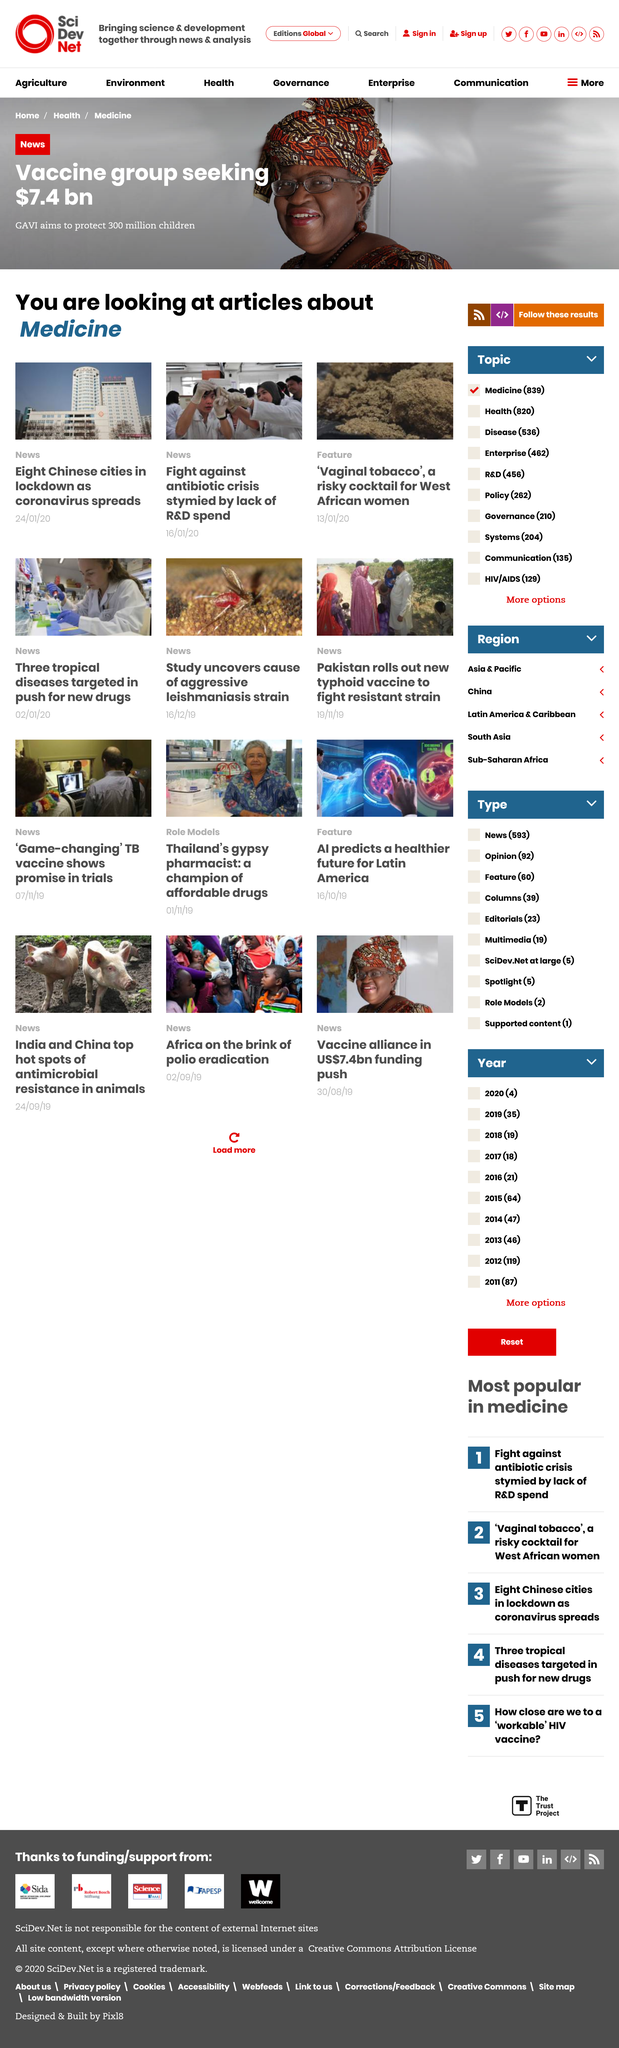Give some essential details in this illustration. GAVI is seeking $7.4 billion in funding to support its mission of improving global health through vaccination. Vaginal tobacco is a hazardous cocktail for West African women, posing a significant risk to their health and wellbeing. Eight Chinese cities are currently under lockdown due to the Coronavirus outbreak. 